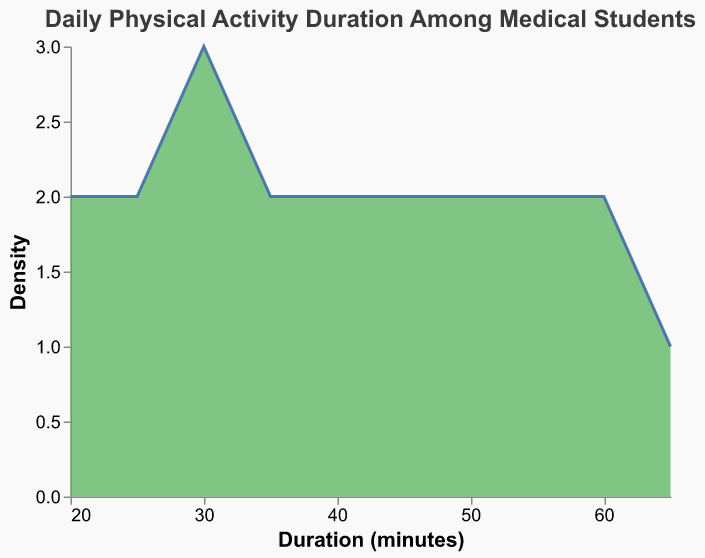What is the title of the plot? The title is located at the top of the figure and is usually distinct in its appearance. The text in the title describes the overall topic of the plot.
Answer: Daily Physical Activity Duration Among Medical Students What is the color used for the density plot? The color used to fill the density plot is visually distinguishable in the figure. This color represents how the data points are displayed.
Answer: Green (#4CAF50) What does the x-axis represent in the plot? The x-axis typically runs horizontally along the bottom of the figure and is labeled to show what data it represents. The label here indicates the unit of measurement being evaluated.
Answer: Duration (minutes) What is the range of Physical Activity Duration in minutes? The range can be determined by examining the minimum and maximum values shown on the x-axis of the plot.
Answer: 20 to 65 minutes Which Physical Activity Duration has the highest density? The highest density corresponds to the peak of the area plot.
Answer: 30 minutes How many days had exactly 25 minutes of physical activity? To determine this, we look at the density value for 25 on the x-axis. This is a density plot, and the y-axis presents a count of occurrences per bin.
Answer: 2 days Which duration range appears to be most common among medical students? We find this by looking at the horizontal section that corresponds to the highest vertical peak in the density plot.
Answer: 30 to 40 minutes Is there more variability at lower or higher durations of physical activity? This can be observed by looking at the width and spread of the density plot at different duration intervals. A wider spread indicates more variability.
Answer: Higher durations Compare the density of physical activity durations of 50 minutes and 55 minutes. Which one is higher? By observing the height of the density plot at the specified durations, we can determine which value has a greater density.
Answer: 50 minutes Does the density plot suggest that most medical students meet the recommended 30 minutes of daily physical activity? The density plot shows where most data points lie. If the peak density is at or above 30 minutes, it suggests that most students meet the recommended duration.
Answer: Yes 